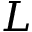Convert formula to latex. <formula><loc_0><loc_0><loc_500><loc_500>L</formula> 